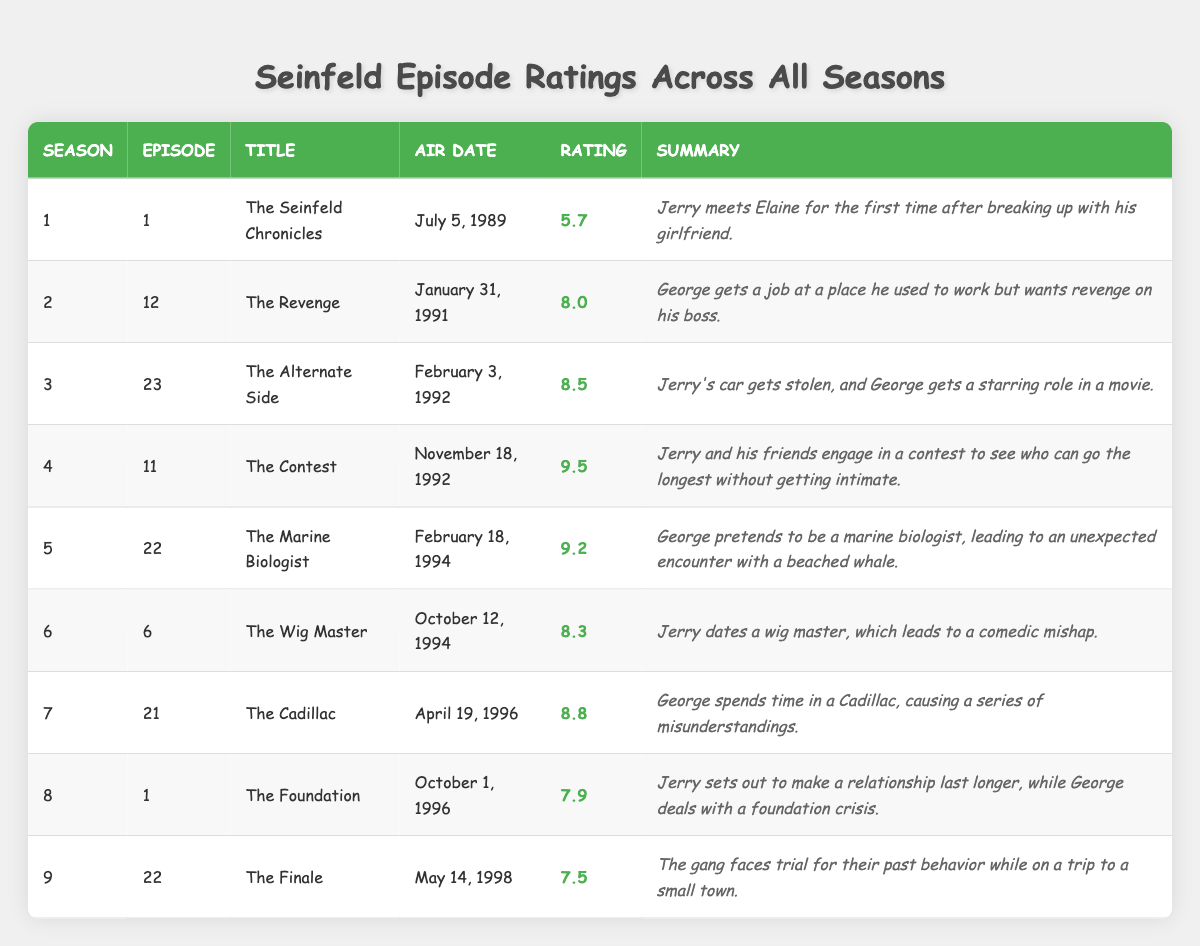What is the highest-rated episode of 'Seinfeld'? The highest rating listed in the table is 9.5 for the episode "The Contest" in Season 4, Episode 11.
Answer: 9.5 Which episode aired first, "The Seinfeld Chronicles" or "The Finale"? "The Seinfeld Chronicles" aired on July 5, 1989, whereas "The Finale" aired on May 14, 1998. "The Seinfeld Chronicles" is the earlier episode.
Answer: "The Seinfeld Chronicles" What was the average rating of episodes from Seasons 5 to 7? The ratings from Seasons 5, 6, and 7 are 9.2, 8.3, and 8.8 respectively. The sum is 9.2 + 8.3 + 8.8 = 26.3. There are 3 episodes, so the average is 26.3 / 3 = 8.767 (rounded to 8.77).
Answer: 8.77 Is the rating of "The Marine Biologist" greater than 8.5? "The Marine Biologist" has a rating of 9.2, which is indeed greater than 8.5.
Answer: Yes Which season has the episode with the lowest rating, and what is that rating? The episode with the lowest rating is from Season 1, Episode 1 titled "The Seinfeld Chronicles," which has a rating of 5.7.
Answer: Season 1, 5.7 How does the rating of "The Contest" compare to "The Finale"? "The Contest" has a rating of 9.5 while "The Finale" has a rating of 7.5. Thus, "The Contest" is rated higher by 2.0 points (9.5 - 7.5).
Answer: Higher by 2.0 points What is the total number of episodes listed in the table? There are 9 episodes listed in the table, each corresponding to a unique season and episode.
Answer: 9 Which season had the highest-rated episode? The highest-rated episode is in Season 4 with "The Contest" rated 9.5.
Answer: Season 4 What is the difference in ratings between "The Cadillac" and "The Foundation"? "The Cadillac" has a rating of 8.8 and "The Foundation" has a rating of 7.9. The difference is 8.8 - 7.9 = 0.9.
Answer: 0.9 What percentage of episodes have ratings above 8.0? Out of the 9 episodes, 5 of them have ratings above 8.0 ("The Revenge," "The Alternate Side," "The Contest," "The Marine Biologist," and "The Cadillac"). Therefore, the percentage is (5/9) * 100 = 55.56%.
Answer: 55.56% Did any episode air in the year 1994? Yes, both "The Marine Biologist" aired on February 18, 1994, and "The Wig Master" aired on October 12, 1994.
Answer: Yes 